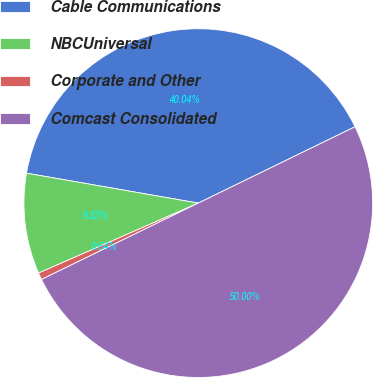Convert chart. <chart><loc_0><loc_0><loc_500><loc_500><pie_chart><fcel>Cable Communications<fcel>NBCUniversal<fcel>Corporate and Other<fcel>Comcast Consolidated<nl><fcel>40.04%<fcel>9.32%<fcel>0.64%<fcel>50.0%<nl></chart> 